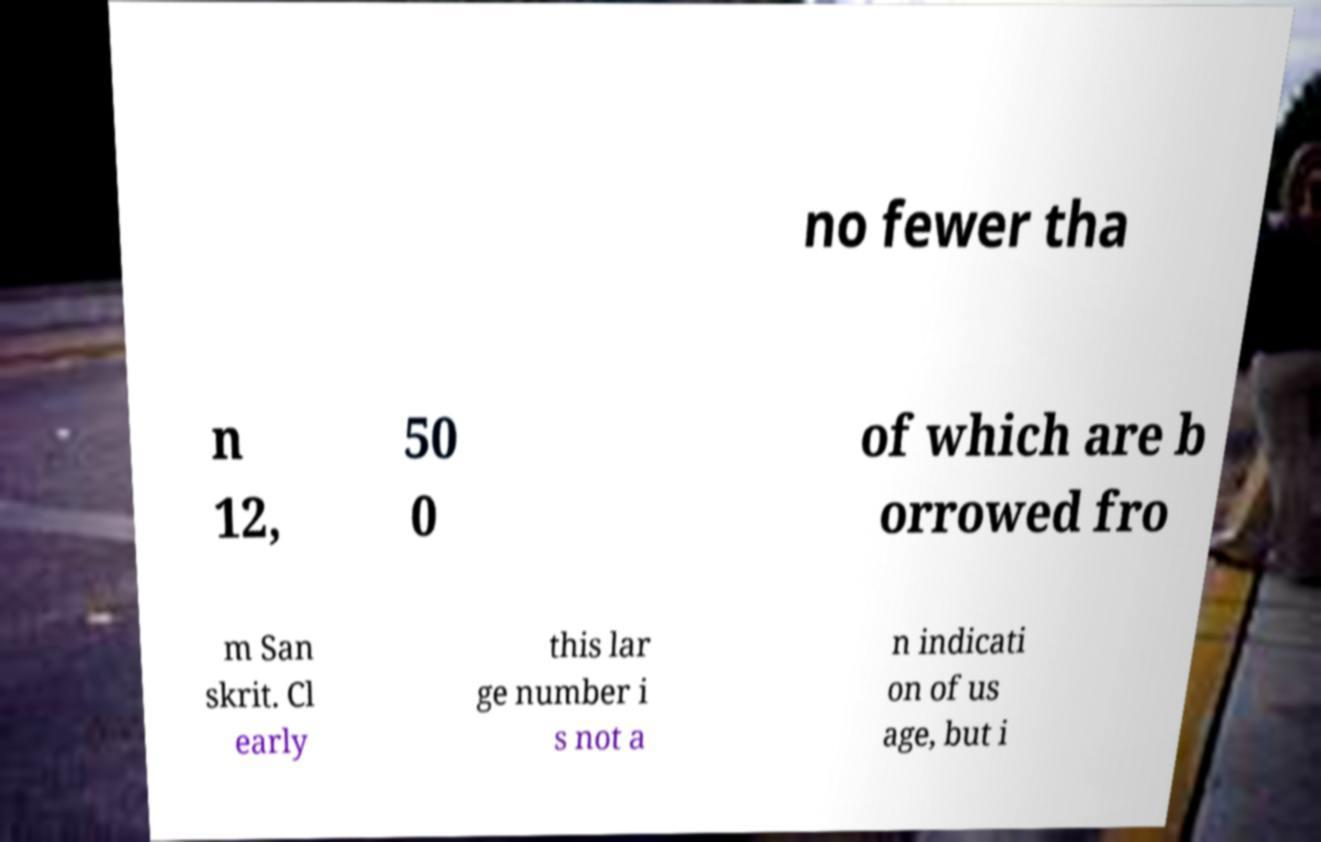Could you extract and type out the text from this image? no fewer tha n 12, 50 0 of which are b orrowed fro m San skrit. Cl early this lar ge number i s not a n indicati on of us age, but i 